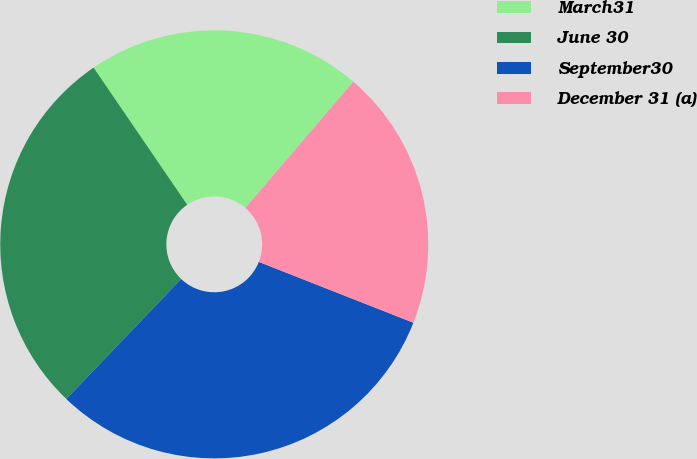Convert chart to OTSL. <chart><loc_0><loc_0><loc_500><loc_500><pie_chart><fcel>March31<fcel>June 30<fcel>September30<fcel>December 31 (a)<nl><fcel>20.79%<fcel>28.32%<fcel>31.18%<fcel>19.71%<nl></chart> 